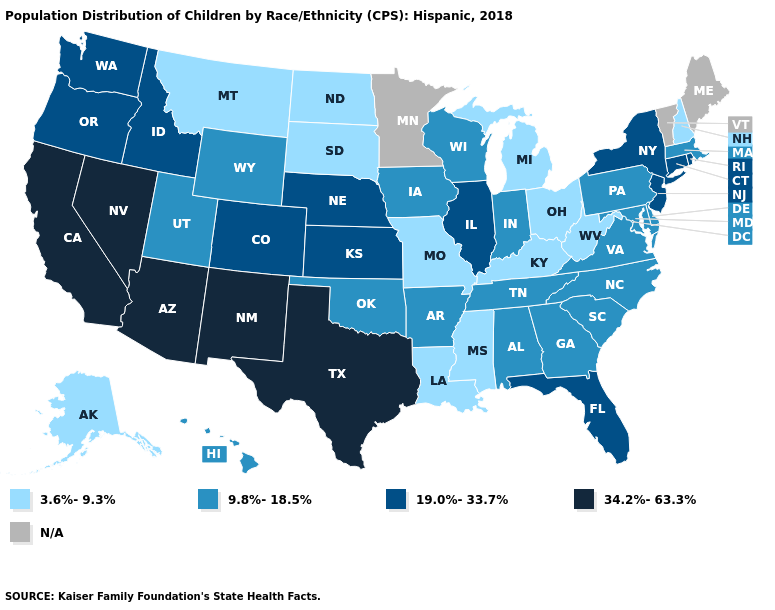Name the states that have a value in the range 3.6%-9.3%?
Give a very brief answer. Alaska, Kentucky, Louisiana, Michigan, Mississippi, Missouri, Montana, New Hampshire, North Dakota, Ohio, South Dakota, West Virginia. Name the states that have a value in the range 9.8%-18.5%?
Give a very brief answer. Alabama, Arkansas, Delaware, Georgia, Hawaii, Indiana, Iowa, Maryland, Massachusetts, North Carolina, Oklahoma, Pennsylvania, South Carolina, Tennessee, Utah, Virginia, Wisconsin, Wyoming. What is the value of Montana?
Concise answer only. 3.6%-9.3%. Does Texas have the highest value in the USA?
Give a very brief answer. Yes. Name the states that have a value in the range 3.6%-9.3%?
Give a very brief answer. Alaska, Kentucky, Louisiana, Michigan, Mississippi, Missouri, Montana, New Hampshire, North Dakota, Ohio, South Dakota, West Virginia. Among the states that border New York , which have the highest value?
Short answer required. Connecticut, New Jersey. Name the states that have a value in the range 19.0%-33.7%?
Be succinct. Colorado, Connecticut, Florida, Idaho, Illinois, Kansas, Nebraska, New Jersey, New York, Oregon, Rhode Island, Washington. Does the first symbol in the legend represent the smallest category?
Quick response, please. Yes. Which states have the highest value in the USA?
Write a very short answer. Arizona, California, Nevada, New Mexico, Texas. Name the states that have a value in the range 3.6%-9.3%?
Write a very short answer. Alaska, Kentucky, Louisiana, Michigan, Mississippi, Missouri, Montana, New Hampshire, North Dakota, Ohio, South Dakota, West Virginia. What is the value of Virginia?
Keep it brief. 9.8%-18.5%. What is the value of Texas?
Quick response, please. 34.2%-63.3%. What is the lowest value in the USA?
Concise answer only. 3.6%-9.3%. What is the value of Washington?
Be succinct. 19.0%-33.7%. Which states have the lowest value in the MidWest?
Be succinct. Michigan, Missouri, North Dakota, Ohio, South Dakota. 